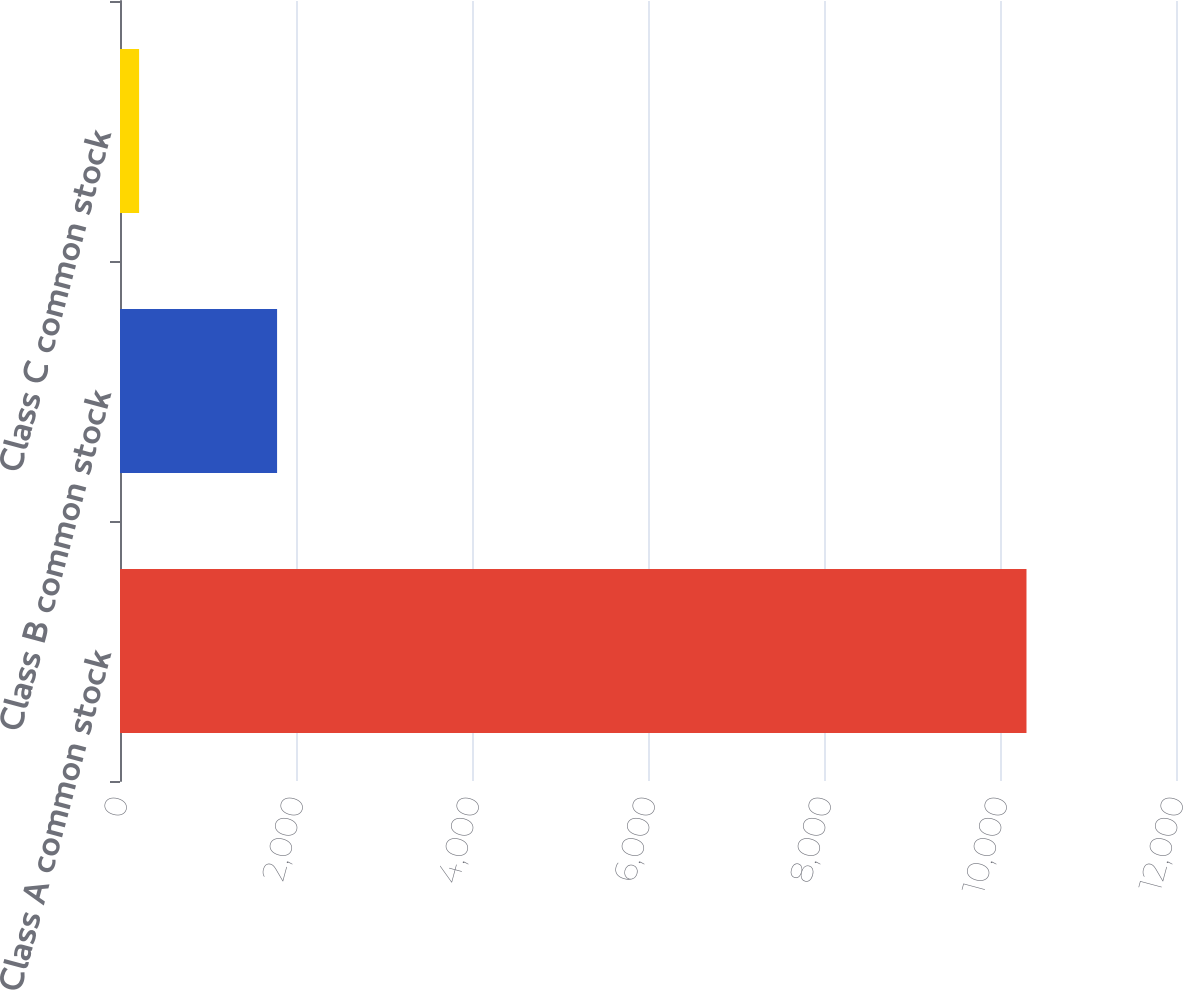Convert chart to OTSL. <chart><loc_0><loc_0><loc_500><loc_500><bar_chart><fcel>Class A common stock<fcel>Class B common stock<fcel>Class C common stock<nl><fcel>10301<fcel>1785<fcel>217<nl></chart> 